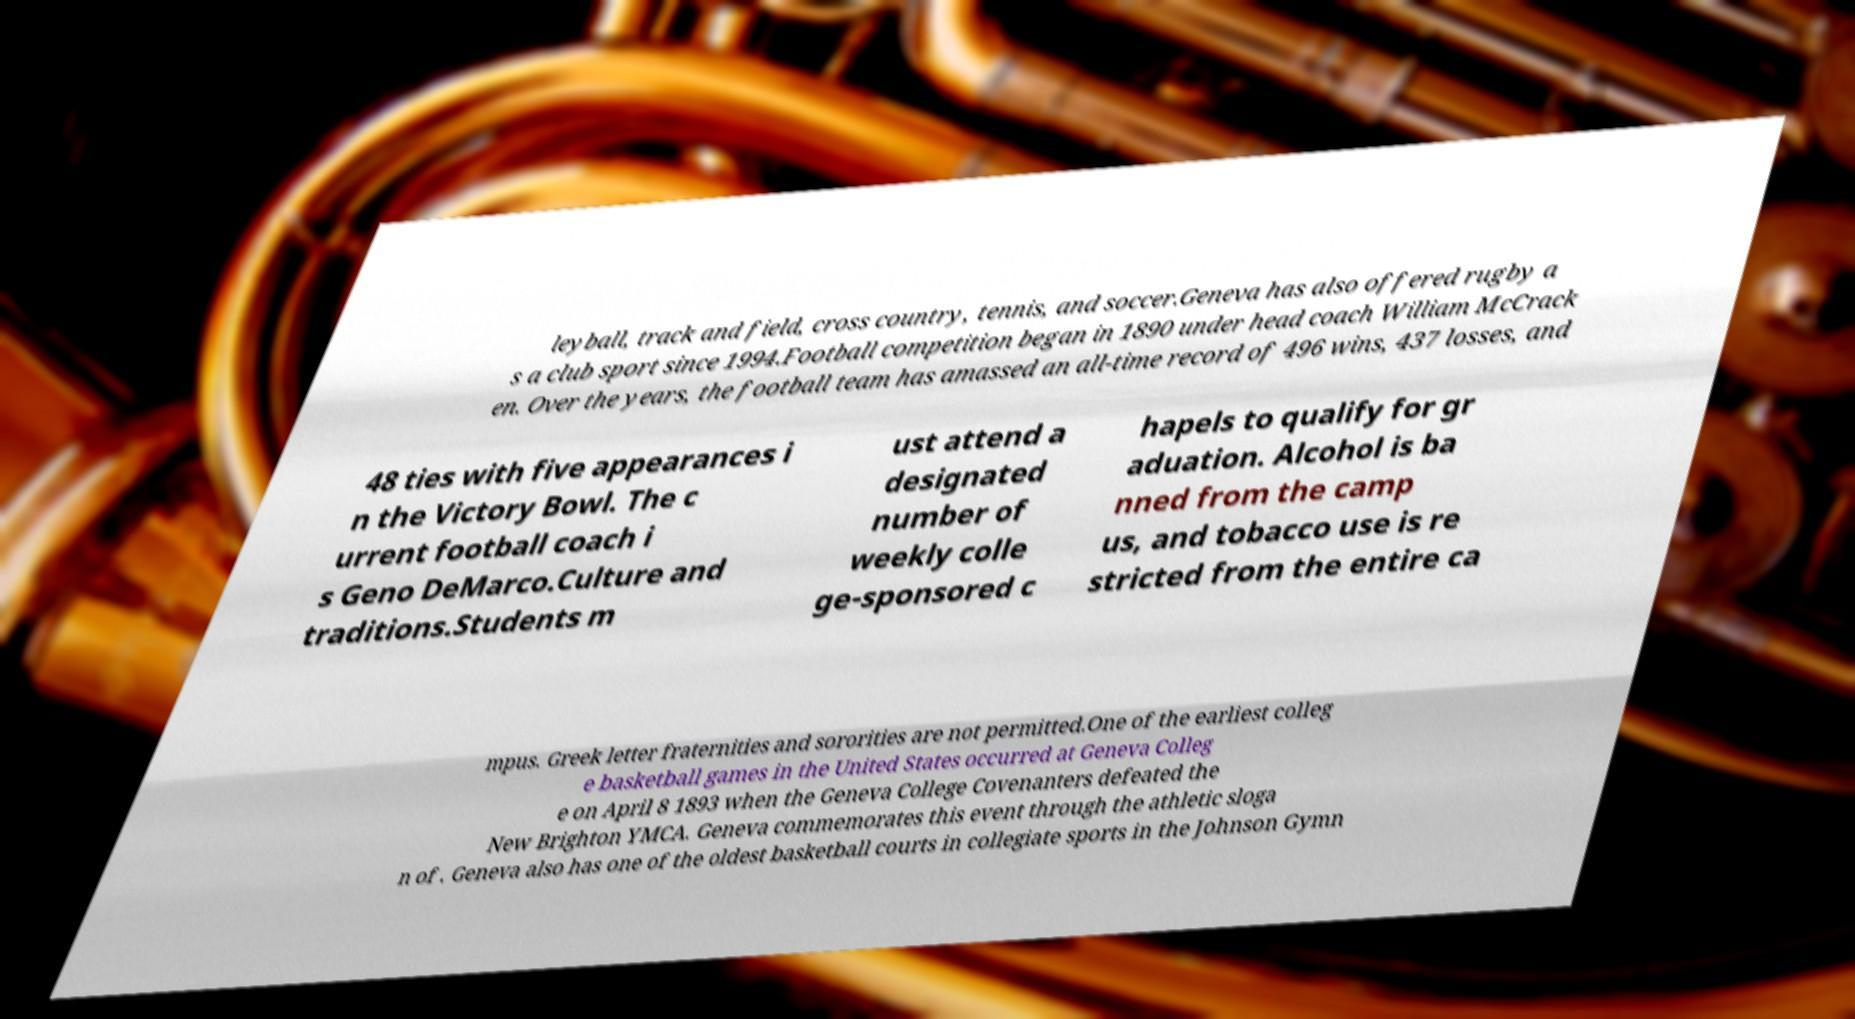There's text embedded in this image that I need extracted. Can you transcribe it verbatim? leyball, track and field, cross country, tennis, and soccer.Geneva has also offered rugby a s a club sport since 1994.Football competition began in 1890 under head coach William McCrack en. Over the years, the football team has amassed an all-time record of 496 wins, 437 losses, and 48 ties with five appearances i n the Victory Bowl. The c urrent football coach i s Geno DeMarco.Culture and traditions.Students m ust attend a designated number of weekly colle ge-sponsored c hapels to qualify for gr aduation. Alcohol is ba nned from the camp us, and tobacco use is re stricted from the entire ca mpus. Greek letter fraternities and sororities are not permitted.One of the earliest colleg e basketball games in the United States occurred at Geneva Colleg e on April 8 1893 when the Geneva College Covenanters defeated the New Brighton YMCA. Geneva commemorates this event through the athletic sloga n of . Geneva also has one of the oldest basketball courts in collegiate sports in the Johnson Gymn 